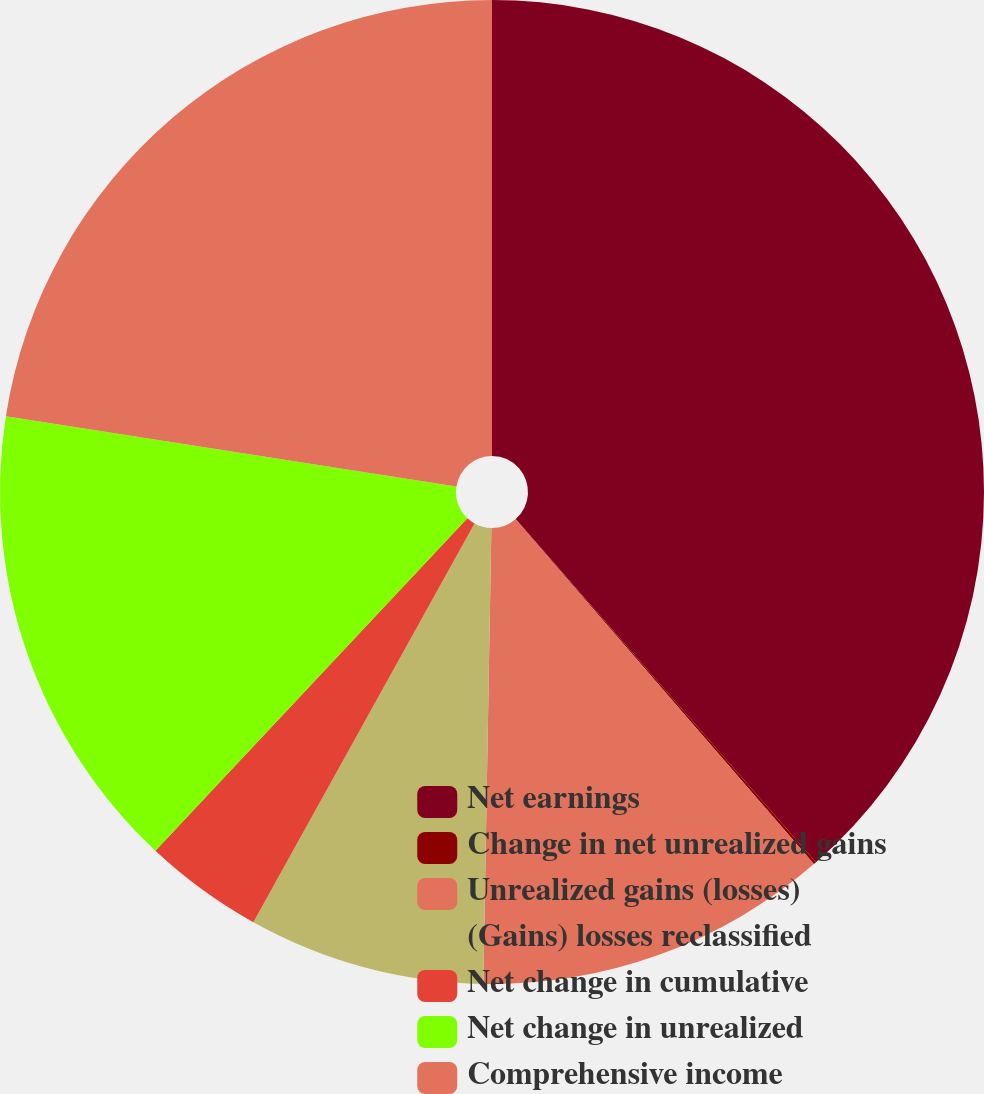Convert chart to OTSL. <chart><loc_0><loc_0><loc_500><loc_500><pie_chart><fcel>Net earnings<fcel>Change in net unrealized gains<fcel>Unrealized gains (losses)<fcel>(Gains) losses reclassified<fcel>Net change in cumulative<fcel>Net change in unrealized<fcel>Comprehensive income<nl><fcel>38.56%<fcel>0.09%<fcel>11.63%<fcel>7.78%<fcel>3.93%<fcel>15.47%<fcel>22.54%<nl></chart> 